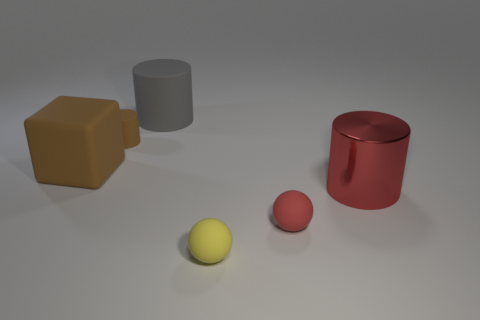There is a cylinder that is the same color as the large block; what is its material?
Make the answer very short. Rubber. Is the shape of the big red metallic object the same as the tiny red thing?
Provide a succinct answer. No. There is another small thing that is the same shape as the tiny red thing; what material is it?
Give a very brief answer. Rubber. Are there any tiny red matte balls that are behind the brown rubber thing that is in front of the rubber cylinder that is in front of the big gray cylinder?
Give a very brief answer. No. There is a gray rubber thing; is its shape the same as the big object on the right side of the yellow object?
Give a very brief answer. Yes. Is there any other thing that is the same color as the big rubber cylinder?
Provide a short and direct response. No. There is a cylinder that is behind the tiny brown cylinder; is its color the same as the cylinder in front of the large block?
Keep it short and to the point. No. Is there a sphere?
Provide a short and direct response. Yes. Are there any cyan blocks that have the same material as the big red thing?
Give a very brief answer. No. Are there any other things that have the same material as the small brown cylinder?
Provide a succinct answer. Yes. 